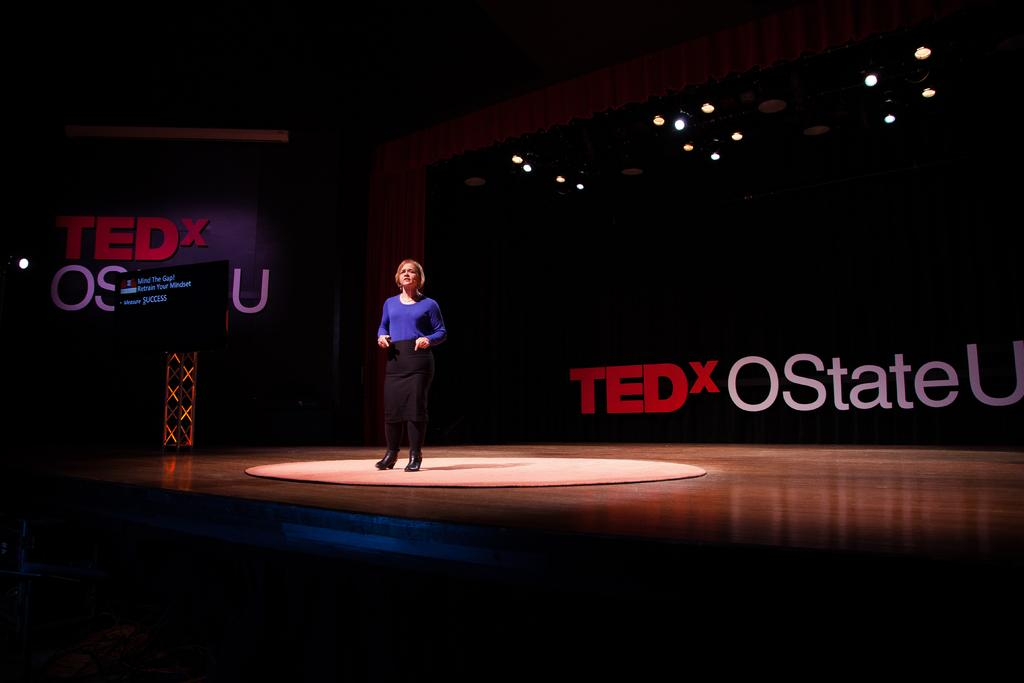What is the woman doing in the image? The woman is standing on a stage in the image. What can be seen in the background of the image? There are banners and lights in the background of the image. What is on the stage with the woman? There is a carpet on the stage in the image. Are there any farm animals visible on the stage with the woman? No, there are no farm animals present in the image. What type of wren can be seen perched on the banner in the background? There is no wren present in the image; only banners and lights are visible in the background. 